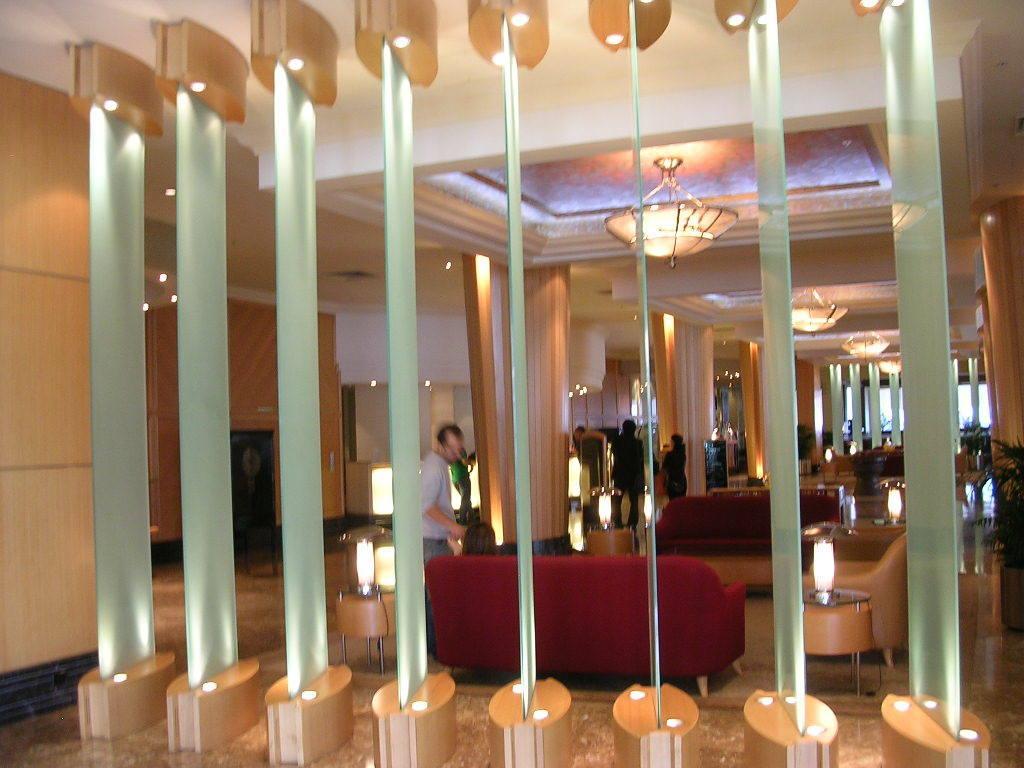Could you give a brief overview of what you see in this image? In this image we can see few people in the image. There are few house plants at the right side of the image. There are many coaches in the image. We can see the inside of a building There are many lights in the image. 